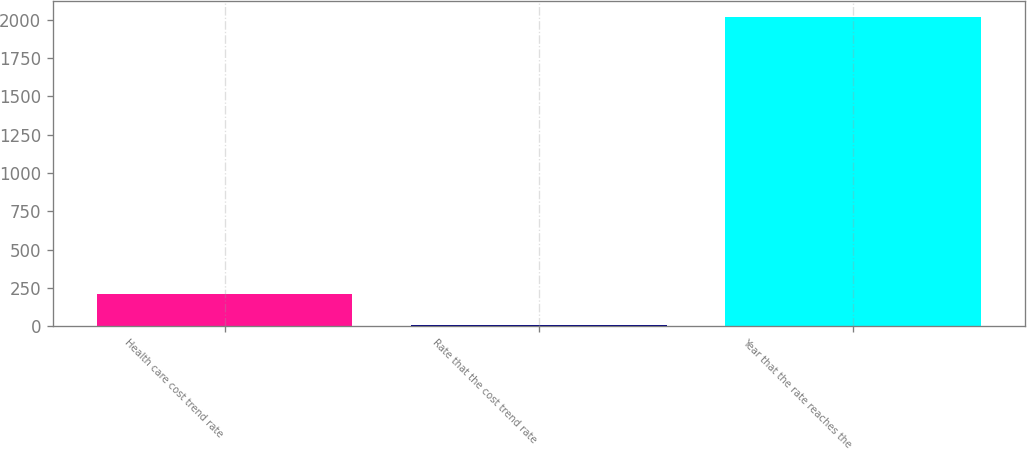<chart> <loc_0><loc_0><loc_500><loc_500><bar_chart><fcel>Health care cost trend rate<fcel>Rate that the cost trend rate<fcel>Year that the rate reaches the<nl><fcel>206.7<fcel>5<fcel>2022<nl></chart> 